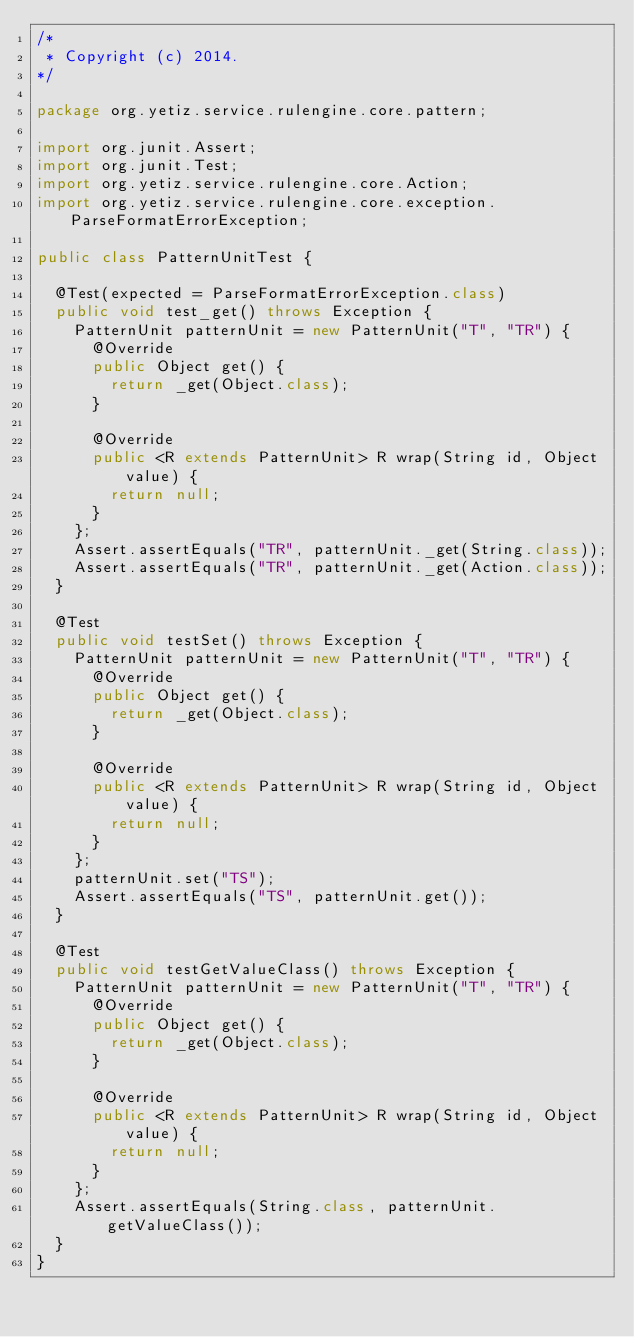<code> <loc_0><loc_0><loc_500><loc_500><_Java_>/*
 * Copyright (c) 2014.
*/

package org.yetiz.service.rulengine.core.pattern;

import org.junit.Assert;
import org.junit.Test;
import org.yetiz.service.rulengine.core.Action;
import org.yetiz.service.rulengine.core.exception.ParseFormatErrorException;

public class PatternUnitTest {

	@Test(expected = ParseFormatErrorException.class)
	public void test_get() throws Exception {
		PatternUnit patternUnit = new PatternUnit("T", "TR") {
			@Override
			public Object get() {
				return _get(Object.class);
			}

			@Override
			public <R extends PatternUnit> R wrap(String id, Object value) {
				return null;
			}
		};
		Assert.assertEquals("TR", patternUnit._get(String.class));
		Assert.assertEquals("TR", patternUnit._get(Action.class));
	}

	@Test
	public void testSet() throws Exception {
		PatternUnit patternUnit = new PatternUnit("T", "TR") {
			@Override
			public Object get() {
				return _get(Object.class);
			}

			@Override
			public <R extends PatternUnit> R wrap(String id, Object value) {
				return null;
			}
		};
		patternUnit.set("TS");
		Assert.assertEquals("TS", patternUnit.get());
	}

	@Test
	public void testGetValueClass() throws Exception {
		PatternUnit patternUnit = new PatternUnit("T", "TR") {
			@Override
			public Object get() {
				return _get(Object.class);
			}

			@Override
			public <R extends PatternUnit> R wrap(String id, Object value) {
				return null;
			}
		};
		Assert.assertEquals(String.class, patternUnit.getValueClass());
	}
}</code> 